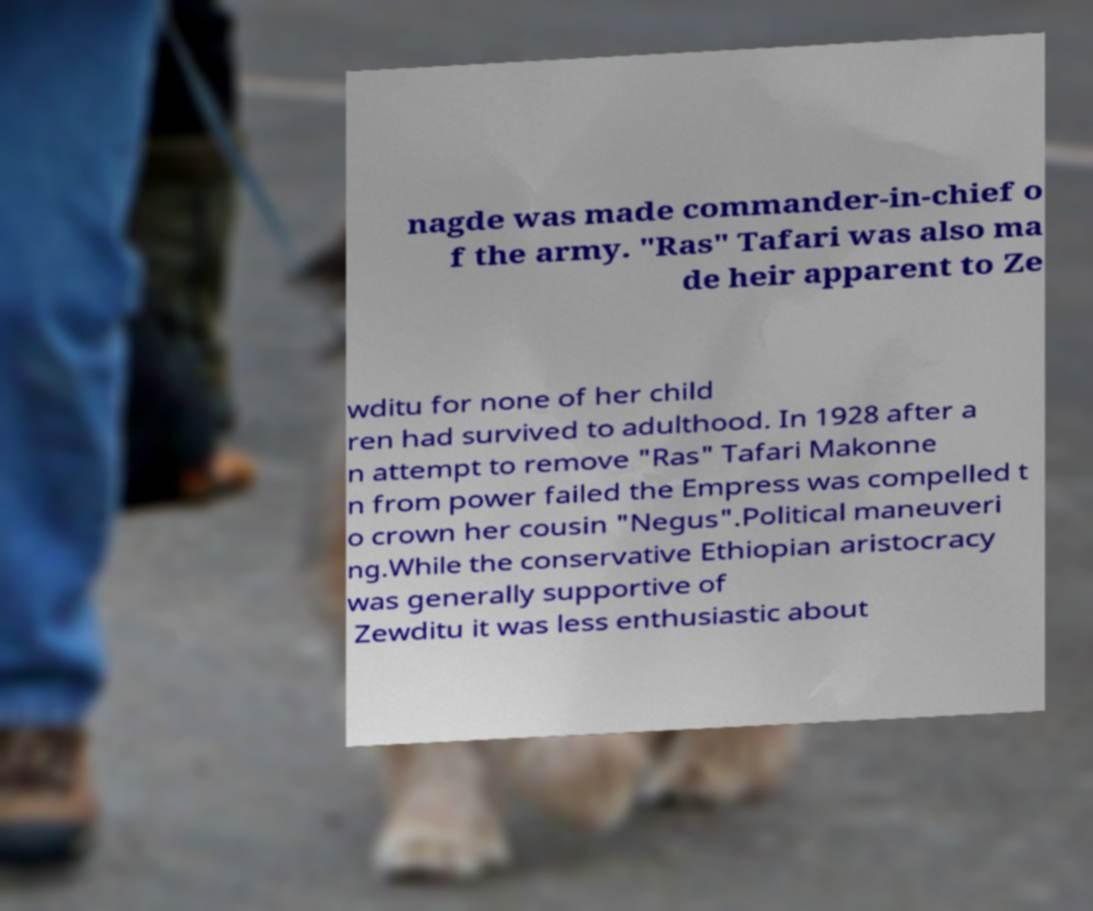Can you read and provide the text displayed in the image?This photo seems to have some interesting text. Can you extract and type it out for me? nagde was made commander-in-chief o f the army. "Ras" Tafari was also ma de heir apparent to Ze wditu for none of her child ren had survived to adulthood. In 1928 after a n attempt to remove "Ras" Tafari Makonne n from power failed the Empress was compelled t o crown her cousin "Negus".Political maneuveri ng.While the conservative Ethiopian aristocracy was generally supportive of Zewditu it was less enthusiastic about 